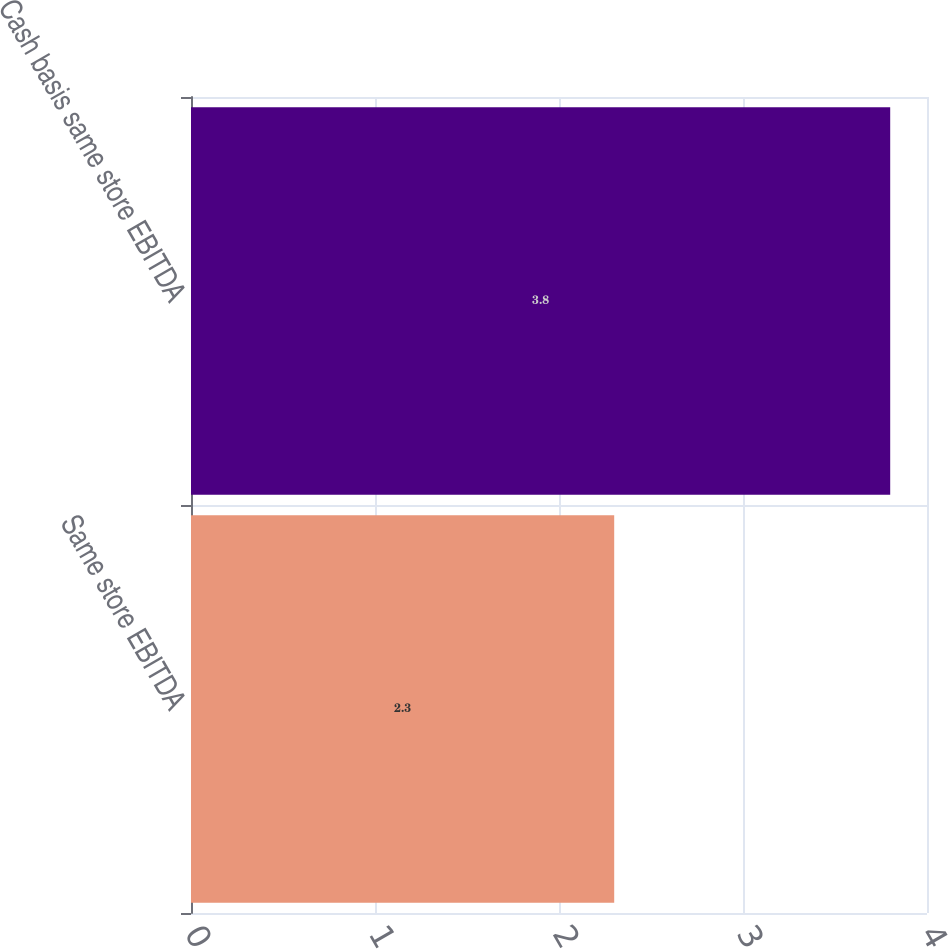<chart> <loc_0><loc_0><loc_500><loc_500><bar_chart><fcel>Same store EBITDA<fcel>Cash basis same store EBITDA<nl><fcel>2.3<fcel>3.8<nl></chart> 